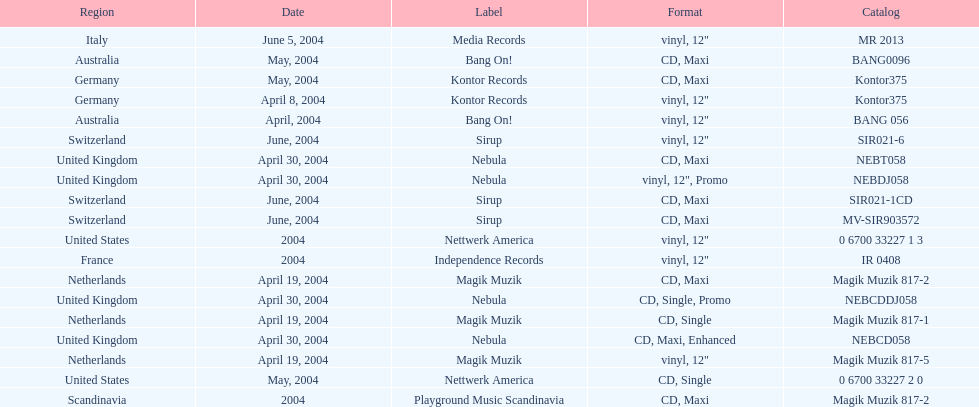Would you mind parsing the complete table? {'header': ['Region', 'Date', 'Label', 'Format', 'Catalog'], 'rows': [['Italy', 'June 5, 2004', 'Media Records', 'vinyl, 12"', 'MR 2013'], ['Australia', 'May, 2004', 'Bang On!', 'CD, Maxi', 'BANG0096'], ['Germany', 'May, 2004', 'Kontor Records', 'CD, Maxi', 'Kontor375'], ['Germany', 'April 8, 2004', 'Kontor Records', 'vinyl, 12"', 'Kontor375'], ['Australia', 'April, 2004', 'Bang On!', 'vinyl, 12"', 'BANG 056'], ['Switzerland', 'June, 2004', 'Sirup', 'vinyl, 12"', 'SIR021-6'], ['United Kingdom', 'April 30, 2004', 'Nebula', 'CD, Maxi', 'NEBT058'], ['United Kingdom', 'April 30, 2004', 'Nebula', 'vinyl, 12", Promo', 'NEBDJ058'], ['Switzerland', 'June, 2004', 'Sirup', 'CD, Maxi', 'SIR021-1CD'], ['Switzerland', 'June, 2004', 'Sirup', 'CD, Maxi', 'MV-SIR903572'], ['United States', '2004', 'Nettwerk America', 'vinyl, 12"', '0 6700 33227 1 3'], ['France', '2004', 'Independence Records', 'vinyl, 12"', 'IR 0408'], ['Netherlands', 'April 19, 2004', 'Magik Muzik', 'CD, Maxi', 'Magik Muzik 817-2'], ['United Kingdom', 'April 30, 2004', 'Nebula', 'CD, Single, Promo', 'NEBCDDJ058'], ['Netherlands', 'April 19, 2004', 'Magik Muzik', 'CD, Single', 'Magik Muzik 817-1'], ['United Kingdom', 'April 30, 2004', 'Nebula', 'CD, Maxi, Enhanced', 'NEBCD058'], ['Netherlands', 'April 19, 2004', 'Magik Muzik', 'vinyl, 12"', 'Magik Muzik 817-5'], ['United States', 'May, 2004', 'Nettwerk America', 'CD, Single', '0 6700 33227 2 0'], ['Scandinavia', '2004', 'Playground Music Scandinavia', 'CD, Maxi', 'Magik Muzik 817-2']]} What format did france use? Vinyl, 12". 